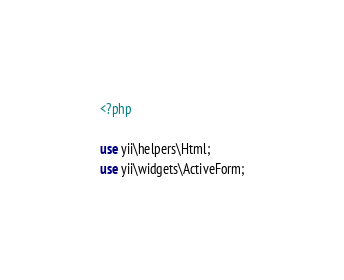Convert code to text. <code><loc_0><loc_0><loc_500><loc_500><_PHP_><?php

use yii\helpers\Html;
use yii\widgets\ActiveForm;
</code> 